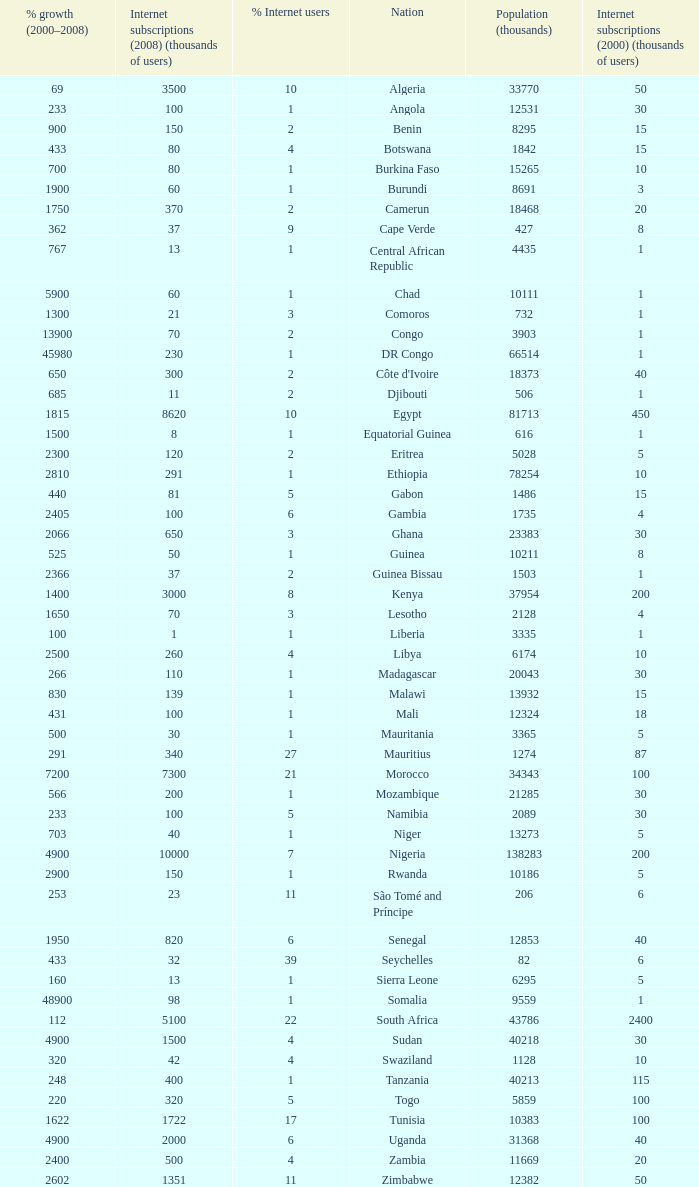Name the total number of percentage growth 2000-2008 of uganda? 1.0. 